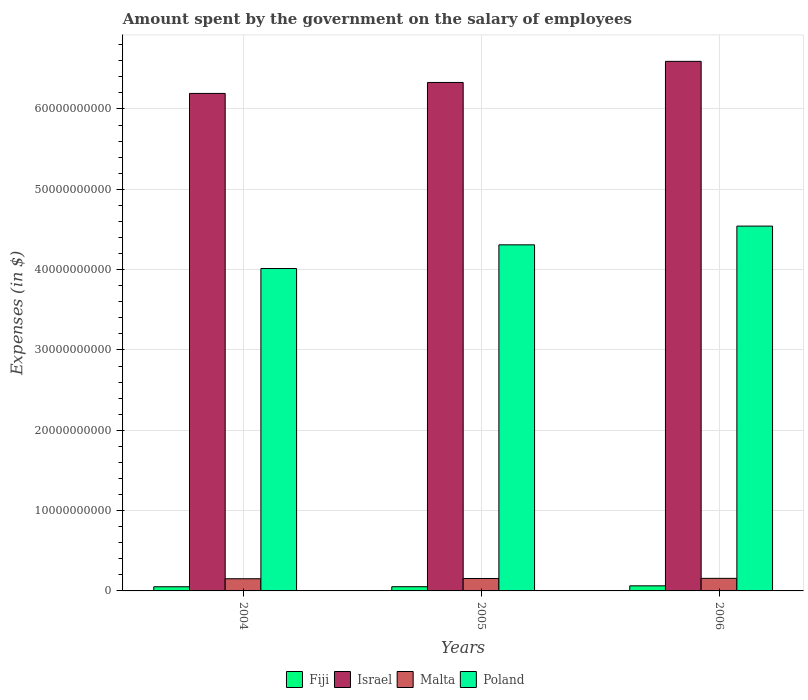How many groups of bars are there?
Your answer should be very brief. 3. Are the number of bars per tick equal to the number of legend labels?
Keep it short and to the point. Yes. What is the label of the 2nd group of bars from the left?
Offer a terse response. 2005. In how many cases, is the number of bars for a given year not equal to the number of legend labels?
Provide a succinct answer. 0. What is the amount spent on the salary of employees by the government in Poland in 2005?
Your answer should be compact. 4.31e+1. Across all years, what is the maximum amount spent on the salary of employees by the government in Israel?
Offer a very short reply. 6.59e+1. Across all years, what is the minimum amount spent on the salary of employees by the government in Israel?
Give a very brief answer. 6.19e+1. In which year was the amount spent on the salary of employees by the government in Poland minimum?
Offer a very short reply. 2004. What is the total amount spent on the salary of employees by the government in Israel in the graph?
Your response must be concise. 1.91e+11. What is the difference between the amount spent on the salary of employees by the government in Israel in 2005 and that in 2006?
Offer a terse response. -2.63e+09. What is the difference between the amount spent on the salary of employees by the government in Malta in 2006 and the amount spent on the salary of employees by the government in Poland in 2004?
Your answer should be very brief. -3.86e+1. What is the average amount spent on the salary of employees by the government in Israel per year?
Ensure brevity in your answer.  6.37e+1. In the year 2005, what is the difference between the amount spent on the salary of employees by the government in Poland and amount spent on the salary of employees by the government in Malta?
Make the answer very short. 4.15e+1. What is the ratio of the amount spent on the salary of employees by the government in Poland in 2004 to that in 2005?
Your answer should be compact. 0.93. Is the amount spent on the salary of employees by the government in Poland in 2005 less than that in 2006?
Offer a very short reply. Yes. What is the difference between the highest and the second highest amount spent on the salary of employees by the government in Israel?
Keep it short and to the point. 2.63e+09. What is the difference between the highest and the lowest amount spent on the salary of employees by the government in Fiji?
Your answer should be compact. 1.13e+08. Is it the case that in every year, the sum of the amount spent on the salary of employees by the government in Malta and amount spent on the salary of employees by the government in Poland is greater than the sum of amount spent on the salary of employees by the government in Fiji and amount spent on the salary of employees by the government in Israel?
Make the answer very short. Yes. What does the 1st bar from the right in 2004 represents?
Make the answer very short. Poland. Are all the bars in the graph horizontal?
Provide a short and direct response. No. How many years are there in the graph?
Provide a succinct answer. 3. What is the difference between two consecutive major ticks on the Y-axis?
Your response must be concise. 1.00e+1. Does the graph contain grids?
Your answer should be very brief. Yes. Where does the legend appear in the graph?
Ensure brevity in your answer.  Bottom center. How many legend labels are there?
Offer a very short reply. 4. How are the legend labels stacked?
Your answer should be compact. Horizontal. What is the title of the graph?
Offer a very short reply. Amount spent by the government on the salary of employees. What is the label or title of the X-axis?
Offer a very short reply. Years. What is the label or title of the Y-axis?
Your answer should be compact. Expenses (in $). What is the Expenses (in $) of Fiji in 2004?
Provide a short and direct response. 5.19e+08. What is the Expenses (in $) of Israel in 2004?
Your response must be concise. 6.19e+1. What is the Expenses (in $) of Malta in 2004?
Your answer should be compact. 1.52e+09. What is the Expenses (in $) in Poland in 2004?
Provide a succinct answer. 4.01e+1. What is the Expenses (in $) of Fiji in 2005?
Offer a very short reply. 5.25e+08. What is the Expenses (in $) of Israel in 2005?
Your answer should be compact. 6.33e+1. What is the Expenses (in $) of Malta in 2005?
Offer a terse response. 1.55e+09. What is the Expenses (in $) of Poland in 2005?
Ensure brevity in your answer.  4.31e+1. What is the Expenses (in $) in Fiji in 2006?
Make the answer very short. 6.32e+08. What is the Expenses (in $) of Israel in 2006?
Offer a very short reply. 6.59e+1. What is the Expenses (in $) in Malta in 2006?
Give a very brief answer. 1.57e+09. What is the Expenses (in $) in Poland in 2006?
Make the answer very short. 4.54e+1. Across all years, what is the maximum Expenses (in $) in Fiji?
Your response must be concise. 6.32e+08. Across all years, what is the maximum Expenses (in $) of Israel?
Make the answer very short. 6.59e+1. Across all years, what is the maximum Expenses (in $) in Malta?
Your answer should be very brief. 1.57e+09. Across all years, what is the maximum Expenses (in $) of Poland?
Offer a very short reply. 4.54e+1. Across all years, what is the minimum Expenses (in $) in Fiji?
Your answer should be compact. 5.19e+08. Across all years, what is the minimum Expenses (in $) in Israel?
Offer a very short reply. 6.19e+1. Across all years, what is the minimum Expenses (in $) in Malta?
Offer a terse response. 1.52e+09. Across all years, what is the minimum Expenses (in $) in Poland?
Provide a succinct answer. 4.01e+1. What is the total Expenses (in $) in Fiji in the graph?
Make the answer very short. 1.68e+09. What is the total Expenses (in $) in Israel in the graph?
Offer a very short reply. 1.91e+11. What is the total Expenses (in $) of Malta in the graph?
Your response must be concise. 4.63e+09. What is the total Expenses (in $) in Poland in the graph?
Offer a terse response. 1.29e+11. What is the difference between the Expenses (in $) of Fiji in 2004 and that in 2005?
Ensure brevity in your answer.  -6.00e+06. What is the difference between the Expenses (in $) of Israel in 2004 and that in 2005?
Your response must be concise. -1.37e+09. What is the difference between the Expenses (in $) of Malta in 2004 and that in 2005?
Keep it short and to the point. -3.07e+07. What is the difference between the Expenses (in $) of Poland in 2004 and that in 2005?
Your response must be concise. -2.95e+09. What is the difference between the Expenses (in $) in Fiji in 2004 and that in 2006?
Your response must be concise. -1.13e+08. What is the difference between the Expenses (in $) in Israel in 2004 and that in 2006?
Provide a short and direct response. -3.99e+09. What is the difference between the Expenses (in $) in Malta in 2004 and that in 2006?
Offer a terse response. -4.90e+07. What is the difference between the Expenses (in $) of Poland in 2004 and that in 2006?
Ensure brevity in your answer.  -5.28e+09. What is the difference between the Expenses (in $) of Fiji in 2005 and that in 2006?
Your response must be concise. -1.07e+08. What is the difference between the Expenses (in $) of Israel in 2005 and that in 2006?
Give a very brief answer. -2.63e+09. What is the difference between the Expenses (in $) in Malta in 2005 and that in 2006?
Ensure brevity in your answer.  -1.82e+07. What is the difference between the Expenses (in $) of Poland in 2005 and that in 2006?
Keep it short and to the point. -2.33e+09. What is the difference between the Expenses (in $) of Fiji in 2004 and the Expenses (in $) of Israel in 2005?
Your answer should be very brief. -6.28e+1. What is the difference between the Expenses (in $) of Fiji in 2004 and the Expenses (in $) of Malta in 2005?
Your answer should be compact. -1.03e+09. What is the difference between the Expenses (in $) of Fiji in 2004 and the Expenses (in $) of Poland in 2005?
Your answer should be compact. -4.26e+1. What is the difference between the Expenses (in $) of Israel in 2004 and the Expenses (in $) of Malta in 2005?
Your response must be concise. 6.04e+1. What is the difference between the Expenses (in $) of Israel in 2004 and the Expenses (in $) of Poland in 2005?
Provide a short and direct response. 1.89e+1. What is the difference between the Expenses (in $) in Malta in 2004 and the Expenses (in $) in Poland in 2005?
Offer a very short reply. -4.16e+1. What is the difference between the Expenses (in $) in Fiji in 2004 and the Expenses (in $) in Israel in 2006?
Your response must be concise. -6.54e+1. What is the difference between the Expenses (in $) of Fiji in 2004 and the Expenses (in $) of Malta in 2006?
Your answer should be compact. -1.05e+09. What is the difference between the Expenses (in $) of Fiji in 2004 and the Expenses (in $) of Poland in 2006?
Your response must be concise. -4.49e+1. What is the difference between the Expenses (in $) in Israel in 2004 and the Expenses (in $) in Malta in 2006?
Your response must be concise. 6.04e+1. What is the difference between the Expenses (in $) of Israel in 2004 and the Expenses (in $) of Poland in 2006?
Give a very brief answer. 1.65e+1. What is the difference between the Expenses (in $) in Malta in 2004 and the Expenses (in $) in Poland in 2006?
Provide a succinct answer. -4.39e+1. What is the difference between the Expenses (in $) in Fiji in 2005 and the Expenses (in $) in Israel in 2006?
Your answer should be very brief. -6.54e+1. What is the difference between the Expenses (in $) of Fiji in 2005 and the Expenses (in $) of Malta in 2006?
Offer a terse response. -1.04e+09. What is the difference between the Expenses (in $) in Fiji in 2005 and the Expenses (in $) in Poland in 2006?
Your response must be concise. -4.49e+1. What is the difference between the Expenses (in $) in Israel in 2005 and the Expenses (in $) in Malta in 2006?
Offer a terse response. 6.17e+1. What is the difference between the Expenses (in $) of Israel in 2005 and the Expenses (in $) of Poland in 2006?
Your response must be concise. 1.79e+1. What is the difference between the Expenses (in $) in Malta in 2005 and the Expenses (in $) in Poland in 2006?
Make the answer very short. -4.39e+1. What is the average Expenses (in $) in Fiji per year?
Keep it short and to the point. 5.59e+08. What is the average Expenses (in $) of Israel per year?
Make the answer very short. 6.37e+1. What is the average Expenses (in $) of Malta per year?
Keep it short and to the point. 1.54e+09. What is the average Expenses (in $) in Poland per year?
Offer a terse response. 4.29e+1. In the year 2004, what is the difference between the Expenses (in $) in Fiji and Expenses (in $) in Israel?
Your answer should be compact. -6.14e+1. In the year 2004, what is the difference between the Expenses (in $) in Fiji and Expenses (in $) in Malta?
Ensure brevity in your answer.  -9.97e+08. In the year 2004, what is the difference between the Expenses (in $) in Fiji and Expenses (in $) in Poland?
Give a very brief answer. -3.96e+1. In the year 2004, what is the difference between the Expenses (in $) in Israel and Expenses (in $) in Malta?
Provide a short and direct response. 6.04e+1. In the year 2004, what is the difference between the Expenses (in $) of Israel and Expenses (in $) of Poland?
Keep it short and to the point. 2.18e+1. In the year 2004, what is the difference between the Expenses (in $) of Malta and Expenses (in $) of Poland?
Your response must be concise. -3.86e+1. In the year 2005, what is the difference between the Expenses (in $) in Fiji and Expenses (in $) in Israel?
Your response must be concise. -6.28e+1. In the year 2005, what is the difference between the Expenses (in $) in Fiji and Expenses (in $) in Malta?
Offer a terse response. -1.02e+09. In the year 2005, what is the difference between the Expenses (in $) in Fiji and Expenses (in $) in Poland?
Make the answer very short. -4.26e+1. In the year 2005, what is the difference between the Expenses (in $) of Israel and Expenses (in $) of Malta?
Make the answer very short. 6.18e+1. In the year 2005, what is the difference between the Expenses (in $) in Israel and Expenses (in $) in Poland?
Provide a succinct answer. 2.02e+1. In the year 2005, what is the difference between the Expenses (in $) of Malta and Expenses (in $) of Poland?
Provide a succinct answer. -4.15e+1. In the year 2006, what is the difference between the Expenses (in $) in Fiji and Expenses (in $) in Israel?
Make the answer very short. -6.53e+1. In the year 2006, what is the difference between the Expenses (in $) in Fiji and Expenses (in $) in Malta?
Provide a short and direct response. -9.33e+08. In the year 2006, what is the difference between the Expenses (in $) in Fiji and Expenses (in $) in Poland?
Offer a terse response. -4.48e+1. In the year 2006, what is the difference between the Expenses (in $) in Israel and Expenses (in $) in Malta?
Your response must be concise. 6.44e+1. In the year 2006, what is the difference between the Expenses (in $) of Israel and Expenses (in $) of Poland?
Your answer should be very brief. 2.05e+1. In the year 2006, what is the difference between the Expenses (in $) in Malta and Expenses (in $) in Poland?
Your answer should be very brief. -4.39e+1. What is the ratio of the Expenses (in $) in Fiji in 2004 to that in 2005?
Give a very brief answer. 0.99. What is the ratio of the Expenses (in $) in Israel in 2004 to that in 2005?
Make the answer very short. 0.98. What is the ratio of the Expenses (in $) in Malta in 2004 to that in 2005?
Keep it short and to the point. 0.98. What is the ratio of the Expenses (in $) in Poland in 2004 to that in 2005?
Give a very brief answer. 0.93. What is the ratio of the Expenses (in $) of Fiji in 2004 to that in 2006?
Keep it short and to the point. 0.82. What is the ratio of the Expenses (in $) of Israel in 2004 to that in 2006?
Offer a terse response. 0.94. What is the ratio of the Expenses (in $) of Malta in 2004 to that in 2006?
Your answer should be compact. 0.97. What is the ratio of the Expenses (in $) in Poland in 2004 to that in 2006?
Provide a succinct answer. 0.88. What is the ratio of the Expenses (in $) in Fiji in 2005 to that in 2006?
Your answer should be very brief. 0.83. What is the ratio of the Expenses (in $) in Israel in 2005 to that in 2006?
Ensure brevity in your answer.  0.96. What is the ratio of the Expenses (in $) in Malta in 2005 to that in 2006?
Ensure brevity in your answer.  0.99. What is the ratio of the Expenses (in $) of Poland in 2005 to that in 2006?
Give a very brief answer. 0.95. What is the difference between the highest and the second highest Expenses (in $) of Fiji?
Your answer should be very brief. 1.07e+08. What is the difference between the highest and the second highest Expenses (in $) of Israel?
Provide a succinct answer. 2.63e+09. What is the difference between the highest and the second highest Expenses (in $) of Malta?
Offer a terse response. 1.82e+07. What is the difference between the highest and the second highest Expenses (in $) in Poland?
Offer a terse response. 2.33e+09. What is the difference between the highest and the lowest Expenses (in $) in Fiji?
Give a very brief answer. 1.13e+08. What is the difference between the highest and the lowest Expenses (in $) in Israel?
Your answer should be very brief. 3.99e+09. What is the difference between the highest and the lowest Expenses (in $) of Malta?
Your answer should be very brief. 4.90e+07. What is the difference between the highest and the lowest Expenses (in $) in Poland?
Your response must be concise. 5.28e+09. 